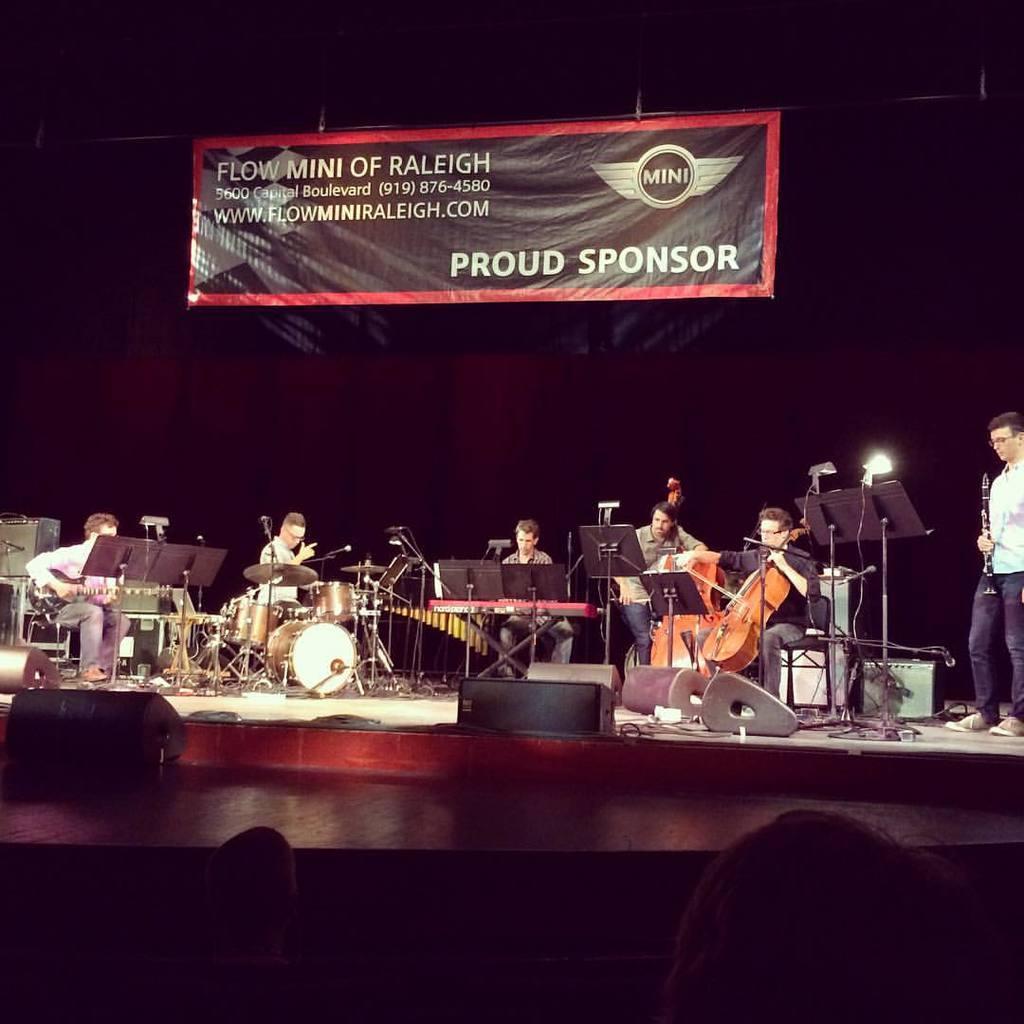Please provide a concise description of this image. There are group of people in image who are playing their musical instruments. In background there is a hoarding in which it is labelled as proud sponsor. In middle there are group of people are sitting as audience. 